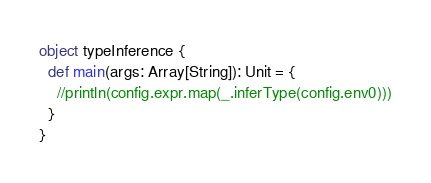<code> <loc_0><loc_0><loc_500><loc_500><_Scala_>object typeInference {
  def main(args: Array[String]): Unit = {
    //println(config.expr.map(_.inferType(config.env0)))
  }
}</code> 